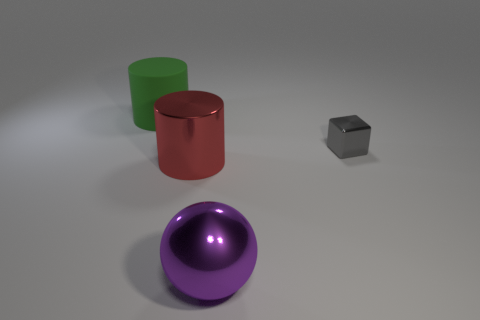How many objects are either large gray metal cylinders or tiny metal objects that are behind the purple object?
Your answer should be compact. 1. Is there another small shiny thing of the same shape as the red shiny object?
Keep it short and to the point. No. What size is the object that is in front of the cylinder that is right of the matte object?
Your answer should be compact. Large. Is the color of the big matte object the same as the tiny cube?
Offer a terse response. No. What number of metal objects are yellow cylinders or large green cylinders?
Offer a very short reply. 0. What number of gray matte blocks are there?
Provide a short and direct response. 0. Is the cylinder behind the tiny metal cube made of the same material as the big cylinder that is in front of the large green thing?
Offer a very short reply. No. The other large rubber object that is the same shape as the large red object is what color?
Provide a succinct answer. Green. There is a cylinder in front of the metallic thing that is right of the large purple metal thing; what is its material?
Your answer should be very brief. Metal. Does the big object behind the gray object have the same shape as the big shiny thing to the left of the big ball?
Your answer should be compact. Yes. 